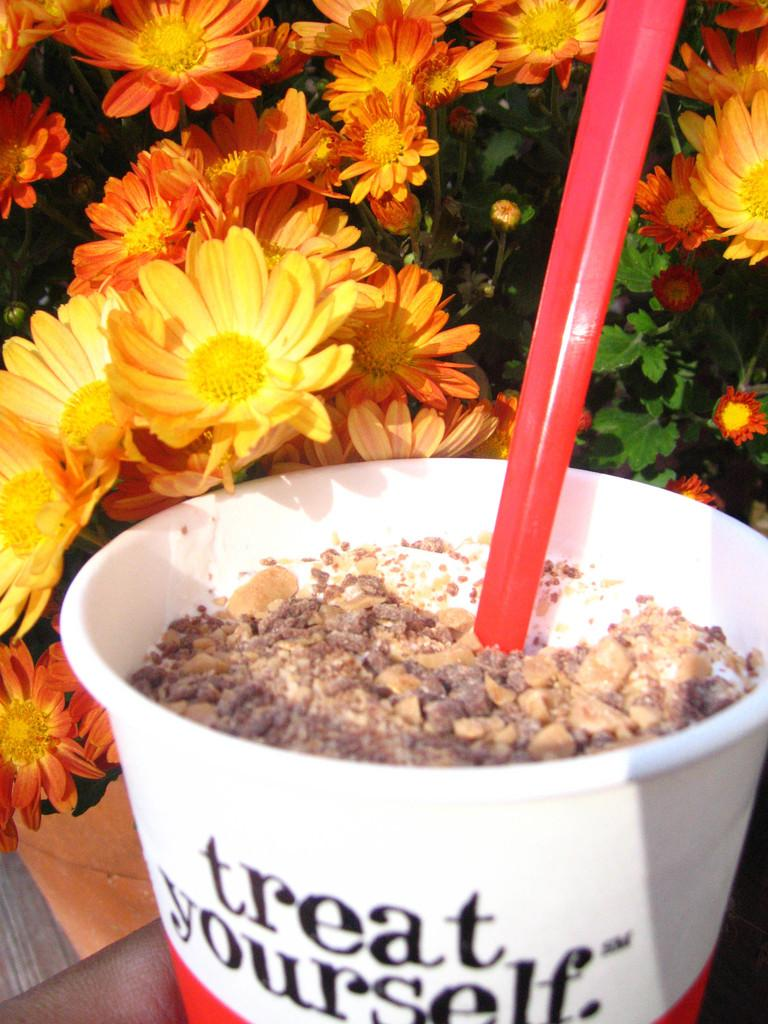What is in the coffee cup that is visible in the image? There is a coffee cup in the image. What is unique about the coffee cup? The coffee cup has a straw. Where is the coffee cup located? The coffee cup is on a table. What type of plant can be seen in the image? There is a flower plant visible in the image. What type of slope can be seen in the image? There is no slope present in the image. Can you tell me how many tanks are visible in the image? There are no tanks present in the image. 